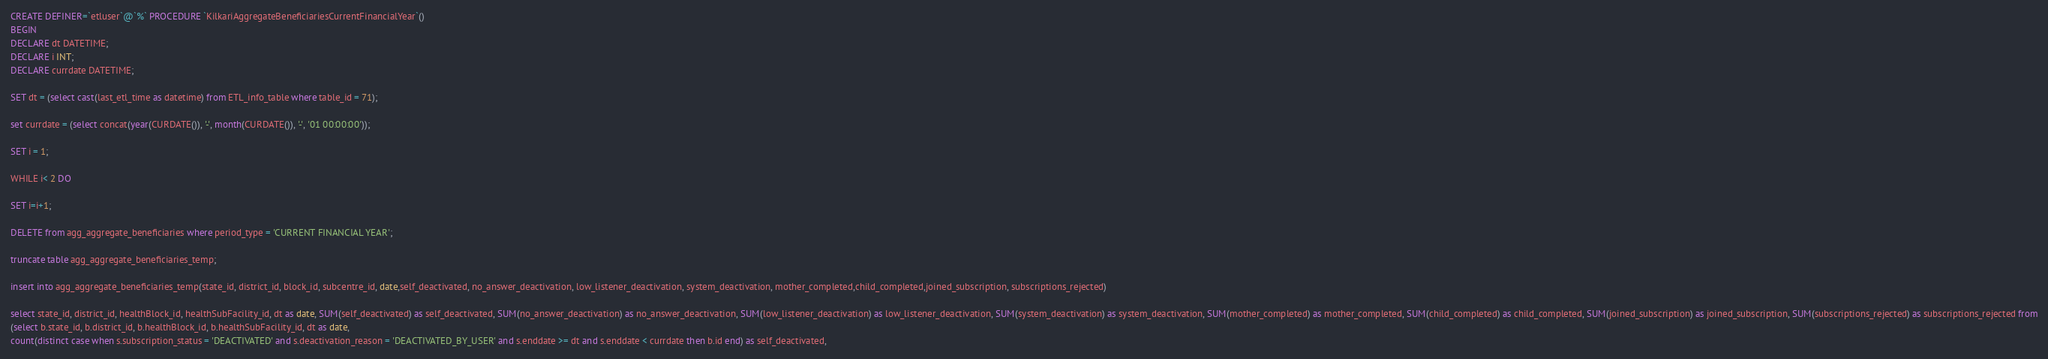<code> <loc_0><loc_0><loc_500><loc_500><_SQL_>CREATE DEFINER=`etluser`@`%` PROCEDURE `KilkariAggregateBeneficiariesCurrentFinancialYear`()
BEGIN
DECLARE dt DATETIME;
DECLARE i INT;
DECLARE currdate DATETIME;

SET dt = (select cast(last_etl_time as datetime) from ETL_info_table where table_id = 71);

set currdate = (select concat(year(CURDATE()), '-', month(CURDATE()), '-', '01 00:00:00'));

SET i = 1;

WHILE i< 2 DO

SET i=i+1;

DELETE from agg_aggregate_beneficiaries where period_type = 'CURRENT FINANCIAL YEAR';

truncate table agg_aggregate_beneficiaries_temp;

insert into agg_aggregate_beneficiaries_temp(state_id, district_id, block_id, subcentre_id, date,self_deactivated, no_answer_deactivation, low_listener_deactivation, system_deactivation, mother_completed,child_completed,joined_subscription, subscriptions_rejected)

select state_id, district_id, healthBlock_id, healthSubFacility_id, dt as date, SUM(self_deactivated) as self_deactivated, SUM(no_answer_deactivation) as no_answer_deactivation, SUM(low_listener_deactivation) as low_listener_deactivation, SUM(system_deactivation) as system_deactivation, SUM(mother_completed) as mother_completed, SUM(child_completed) as child_completed, SUM(joined_subscription) as joined_subscription, SUM(subscriptions_rejected) as subscriptions_rejected from
(select b.state_id, b.district_id, b.healthBlock_id, b.healthSubFacility_id, dt as date,
count(distinct case when s.subscription_status = 'DEACTIVATED' and s.deactivation_reason = 'DEACTIVATED_BY_USER' and s.enddate >= dt and s.enddate < currdate then b.id end) as self_deactivated,</code> 